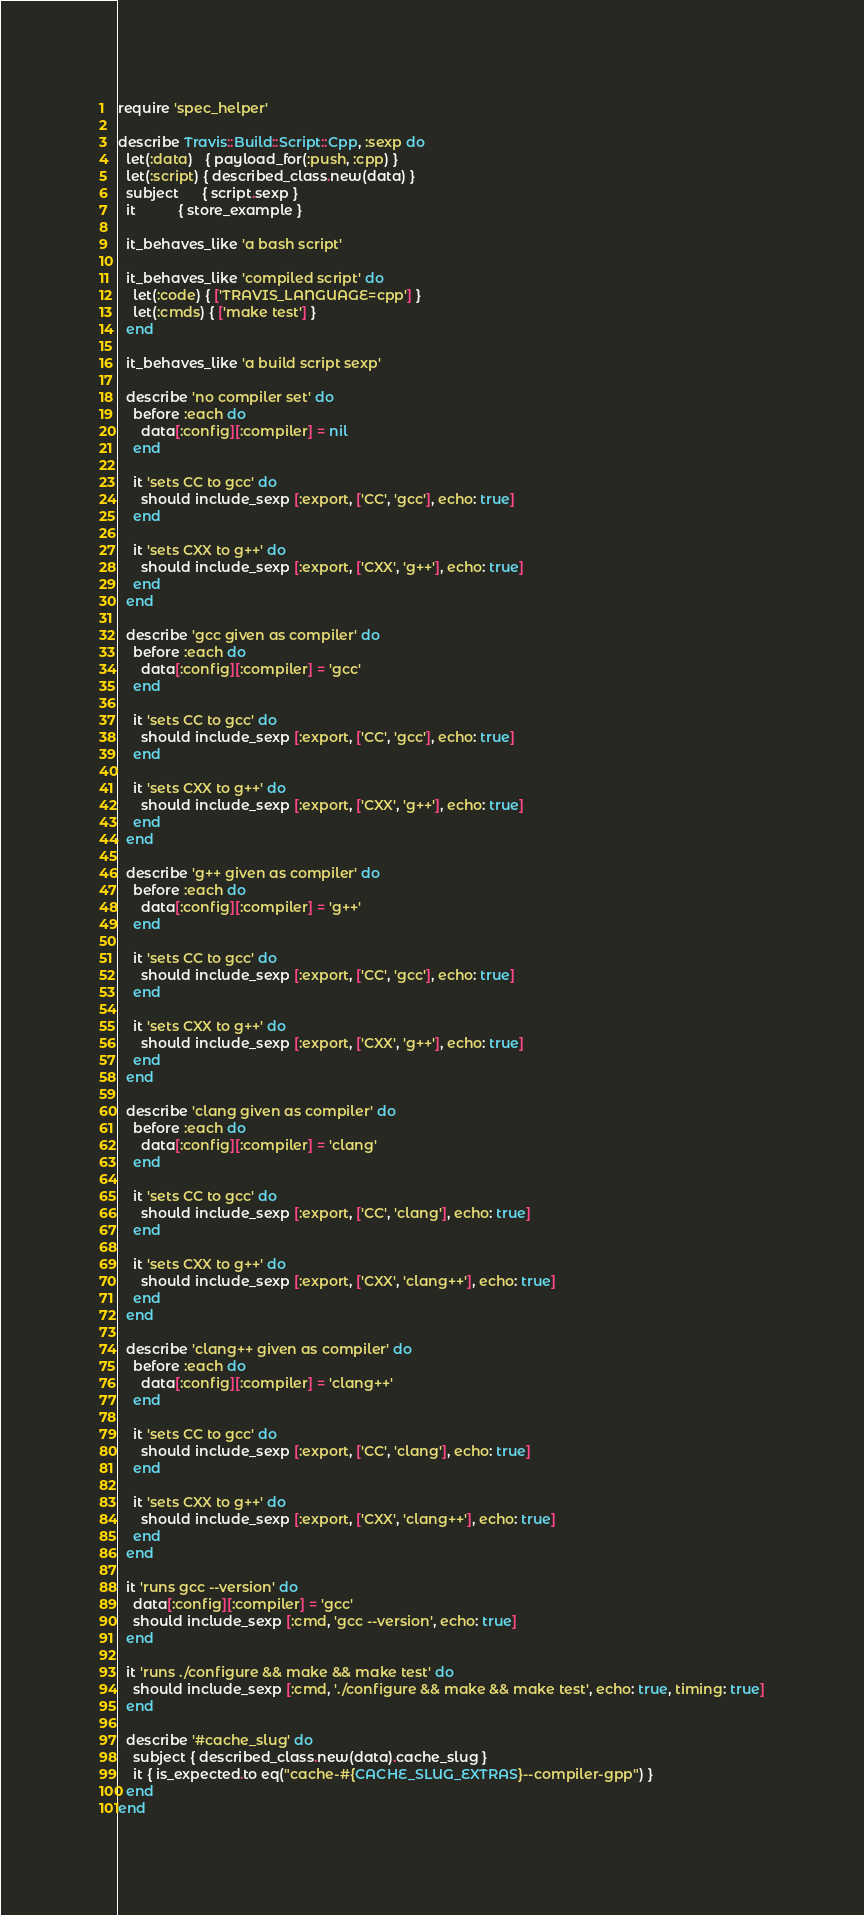Convert code to text. <code><loc_0><loc_0><loc_500><loc_500><_Ruby_>require 'spec_helper'

describe Travis::Build::Script::Cpp, :sexp do
  let(:data)   { payload_for(:push, :cpp) }
  let(:script) { described_class.new(data) }
  subject      { script.sexp }
  it           { store_example }

  it_behaves_like 'a bash script'

  it_behaves_like 'compiled script' do
    let(:code) { ['TRAVIS_LANGUAGE=cpp'] }
    let(:cmds) { ['make test'] }
  end

  it_behaves_like 'a build script sexp'

  describe 'no compiler set' do
    before :each do
      data[:config][:compiler] = nil
    end

    it 'sets CC to gcc' do
      should include_sexp [:export, ['CC', 'gcc'], echo: true]
    end

    it 'sets CXX to g++' do
      should include_sexp [:export, ['CXX', 'g++'], echo: true]
    end
  end

  describe 'gcc given as compiler' do
    before :each do
      data[:config][:compiler] = 'gcc'
    end

    it 'sets CC to gcc' do
      should include_sexp [:export, ['CC', 'gcc'], echo: true]
    end

    it 'sets CXX to g++' do
      should include_sexp [:export, ['CXX', 'g++'], echo: true]
    end
  end

  describe 'g++ given as compiler' do
    before :each do
      data[:config][:compiler] = 'g++'
    end

    it 'sets CC to gcc' do
      should include_sexp [:export, ['CC', 'gcc'], echo: true]
    end

    it 'sets CXX to g++' do
      should include_sexp [:export, ['CXX', 'g++'], echo: true]
    end
  end

  describe 'clang given as compiler' do
    before :each do
      data[:config][:compiler] = 'clang'
    end

    it 'sets CC to gcc' do
      should include_sexp [:export, ['CC', 'clang'], echo: true]
    end

    it 'sets CXX to g++' do
      should include_sexp [:export, ['CXX', 'clang++'], echo: true]
    end
  end

  describe 'clang++ given as compiler' do
    before :each do
      data[:config][:compiler] = 'clang++'
    end

    it 'sets CC to gcc' do
      should include_sexp [:export, ['CC', 'clang'], echo: true]
    end

    it 'sets CXX to g++' do
      should include_sexp [:export, ['CXX', 'clang++'], echo: true]
    end
  end

  it 'runs gcc --version' do
    data[:config][:compiler] = 'gcc'
    should include_sexp [:cmd, 'gcc --version', echo: true]
  end

  it 'runs ./configure && make && make test' do
    should include_sexp [:cmd, './configure && make && make test', echo: true, timing: true]
  end

  describe '#cache_slug' do
    subject { described_class.new(data).cache_slug }
    it { is_expected.to eq("cache-#{CACHE_SLUG_EXTRAS}--compiler-gpp") }
  end
end
</code> 